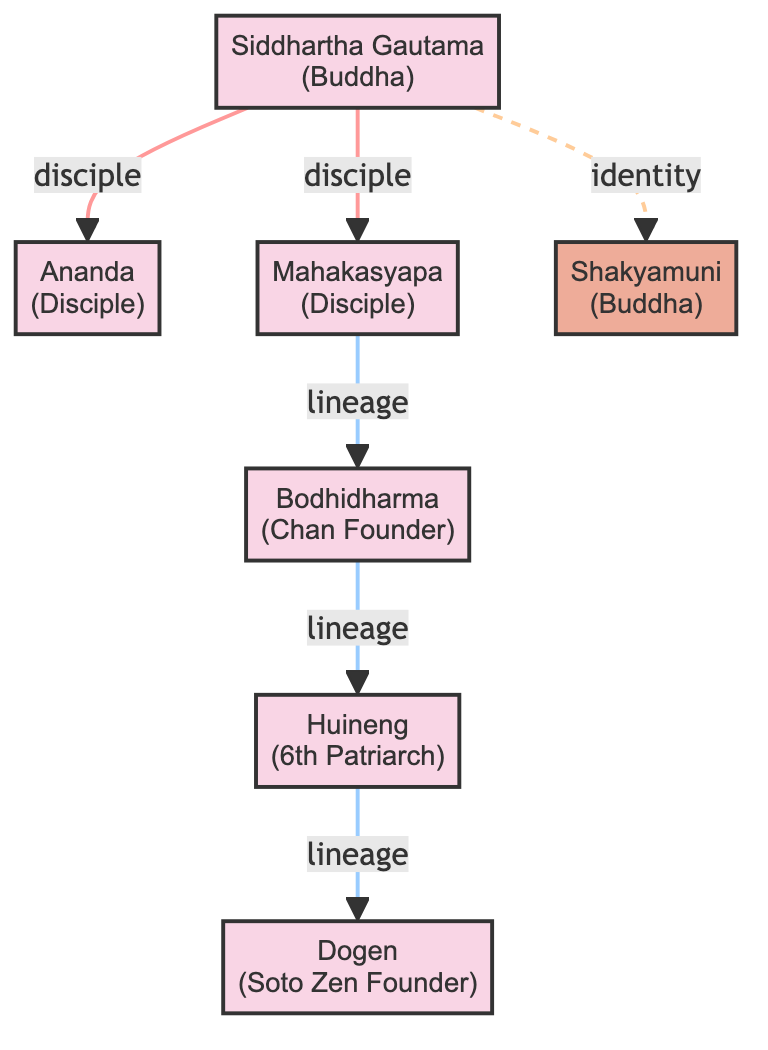What is the relationship between Siddhartha Gautama and Ananda? The diagram shows a directed edge from Siddhartha Gautama to Ananda labeled as "disciple", indicating that Ananda is a disciple of Siddhartha Gautama.
Answer: disciple How many nodes are present in the diagram? Counting the nodes shown in the diagram, there are a total of 7, which include Siddhartha Gautama, Ananda, Mahakasyapa, Bodhidharma, Huineng, Dogen, and Shakyamuni.
Answer: 7 Who is the sixth Patriarch of Chan Buddhism? The diagram identifies Huineng as the sixth Patriarch of Chan Buddhism, as indicated in the label next to his node.
Answer: Huineng Which figure is directly connected to Bodhidharma? The directed edge in the diagram shows that Huineng is directly connected to Bodhidharma with the relationship "lineage," meaning Huineng is a successor in the lineage.
Answer: Huineng What is the relationship type between Mahakasyapa and Bodhidharma? The diagram indicates a directed edge from Mahakasyapa to Bodhidharma with the label "lineage", meaning Mahakasyapa has passed down teachings to Bodhidharma in a lineage context.
Answer: lineage How many edges are there in total? By examining the connections in the diagram, there are 6 directed edges, representing the relationships among the figures.
Answer: 6 What is the significance of the dashed line from Siddhartha Gautama to Shakyamuni? The dashed line from Siddhartha Gautama to Shakyamuni indicates an identity relationship, suggesting that they represent the same historical figure, the Buddha.
Answer: identity Who is the founder of the Soto school of Zen? The diagram labels Dogen as the founder of the Soto school of Zen in Japan, based on the text next to his node.
Answer: Dogen 